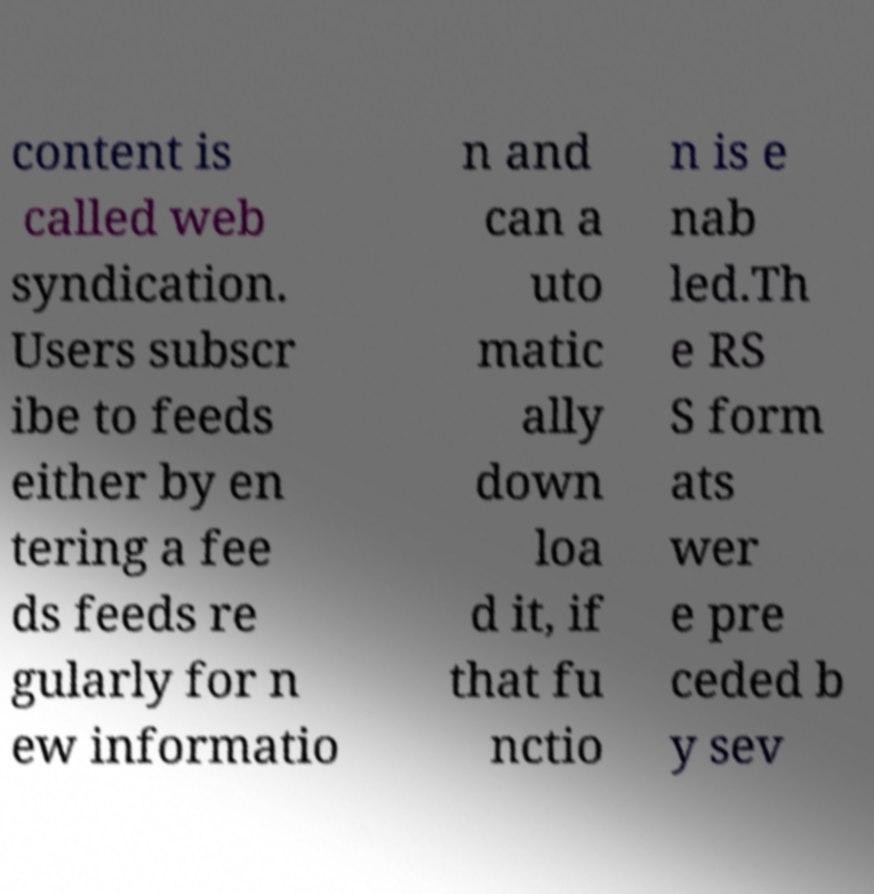What messages or text are displayed in this image? I need them in a readable, typed format. content is called web syndication. Users subscr ibe to feeds either by en tering a fee ds feeds re gularly for n ew informatio n and can a uto matic ally down loa d it, if that fu nctio n is e nab led.Th e RS S form ats wer e pre ceded b y sev 